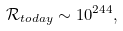Convert formula to latex. <formula><loc_0><loc_0><loc_500><loc_500>\mathcal { R } _ { t o d a y } \sim 1 0 ^ { 2 4 4 } ,</formula> 